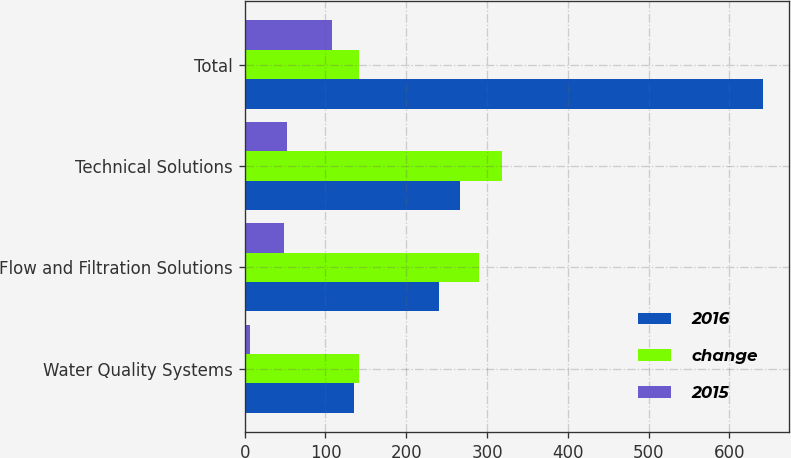Convert chart to OTSL. <chart><loc_0><loc_0><loc_500><loc_500><stacked_bar_chart><ecel><fcel>Water Quality Systems<fcel>Flow and Filtration Solutions<fcel>Technical Solutions<fcel>Total<nl><fcel>2016<fcel>134.8<fcel>241<fcel>266.3<fcel>642.1<nl><fcel>change<fcel>141.4<fcel>289.6<fcel>319<fcel>141.4<nl><fcel>2015<fcel>6.6<fcel>48.6<fcel>52.7<fcel>107.9<nl></chart> 